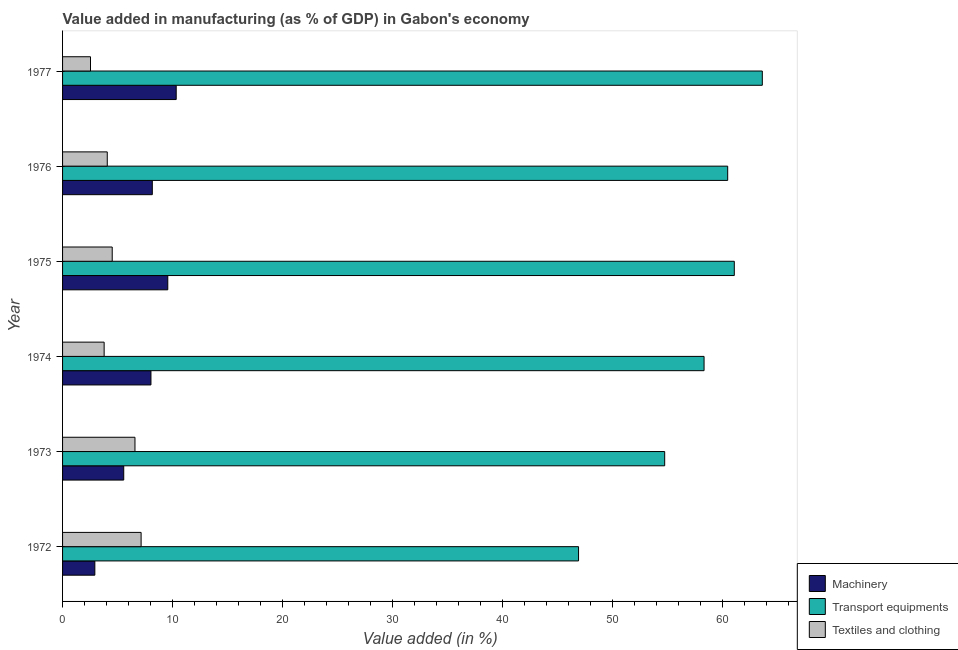How many groups of bars are there?
Give a very brief answer. 6. What is the label of the 3rd group of bars from the top?
Offer a very short reply. 1975. What is the value added in manufacturing machinery in 1977?
Keep it short and to the point. 10.33. Across all years, what is the maximum value added in manufacturing transport equipments?
Provide a short and direct response. 63.58. Across all years, what is the minimum value added in manufacturing textile and clothing?
Provide a succinct answer. 2.54. In which year was the value added in manufacturing transport equipments maximum?
Your answer should be very brief. 1977. In which year was the value added in manufacturing transport equipments minimum?
Make the answer very short. 1972. What is the total value added in manufacturing transport equipments in the graph?
Your answer should be very brief. 344.92. What is the difference between the value added in manufacturing machinery in 1974 and that in 1976?
Provide a short and direct response. -0.12. What is the difference between the value added in manufacturing machinery in 1975 and the value added in manufacturing transport equipments in 1974?
Your answer should be compact. -48.73. What is the average value added in manufacturing textile and clothing per year?
Your response must be concise. 4.77. In the year 1973, what is the difference between the value added in manufacturing transport equipments and value added in manufacturing machinery?
Your response must be concise. 49.15. What is the ratio of the value added in manufacturing textile and clothing in 1972 to that in 1975?
Your response must be concise. 1.58. Is the difference between the value added in manufacturing transport equipments in 1975 and 1977 greater than the difference between the value added in manufacturing machinery in 1975 and 1977?
Make the answer very short. No. What is the difference between the highest and the second highest value added in manufacturing machinery?
Provide a short and direct response. 0.77. Is the sum of the value added in manufacturing transport equipments in 1976 and 1977 greater than the maximum value added in manufacturing machinery across all years?
Give a very brief answer. Yes. What does the 1st bar from the top in 1976 represents?
Your answer should be compact. Textiles and clothing. What does the 1st bar from the bottom in 1976 represents?
Give a very brief answer. Machinery. Is it the case that in every year, the sum of the value added in manufacturing machinery and value added in manufacturing transport equipments is greater than the value added in manufacturing textile and clothing?
Give a very brief answer. Yes. How many bars are there?
Keep it short and to the point. 18. How many years are there in the graph?
Your answer should be very brief. 6. What is the difference between two consecutive major ticks on the X-axis?
Offer a very short reply. 10. Does the graph contain grids?
Ensure brevity in your answer.  No. Where does the legend appear in the graph?
Keep it short and to the point. Bottom right. How are the legend labels stacked?
Your answer should be compact. Vertical. What is the title of the graph?
Ensure brevity in your answer.  Value added in manufacturing (as % of GDP) in Gabon's economy. Does "Female employers" appear as one of the legend labels in the graph?
Provide a succinct answer. No. What is the label or title of the X-axis?
Give a very brief answer. Value added (in %). What is the Value added (in %) in Machinery in 1972?
Ensure brevity in your answer.  2.93. What is the Value added (in %) of Transport equipments in 1972?
Ensure brevity in your answer.  46.88. What is the Value added (in %) of Textiles and clothing in 1972?
Your answer should be compact. 7.14. What is the Value added (in %) of Machinery in 1973?
Provide a short and direct response. 5.56. What is the Value added (in %) in Transport equipments in 1973?
Your response must be concise. 54.71. What is the Value added (in %) of Textiles and clothing in 1973?
Offer a terse response. 6.58. What is the Value added (in %) in Machinery in 1974?
Your answer should be very brief. 8.03. What is the Value added (in %) of Transport equipments in 1974?
Your response must be concise. 58.29. What is the Value added (in %) in Textiles and clothing in 1974?
Offer a very short reply. 3.78. What is the Value added (in %) in Machinery in 1975?
Your response must be concise. 9.56. What is the Value added (in %) of Transport equipments in 1975?
Make the answer very short. 61.03. What is the Value added (in %) in Textiles and clothing in 1975?
Make the answer very short. 4.51. What is the Value added (in %) in Machinery in 1976?
Give a very brief answer. 8.16. What is the Value added (in %) in Transport equipments in 1976?
Offer a terse response. 60.43. What is the Value added (in %) in Textiles and clothing in 1976?
Provide a succinct answer. 4.06. What is the Value added (in %) in Machinery in 1977?
Your answer should be very brief. 10.33. What is the Value added (in %) of Transport equipments in 1977?
Provide a short and direct response. 63.58. What is the Value added (in %) of Textiles and clothing in 1977?
Provide a succinct answer. 2.54. Across all years, what is the maximum Value added (in %) in Machinery?
Offer a very short reply. 10.33. Across all years, what is the maximum Value added (in %) of Transport equipments?
Ensure brevity in your answer.  63.58. Across all years, what is the maximum Value added (in %) in Textiles and clothing?
Give a very brief answer. 7.14. Across all years, what is the minimum Value added (in %) in Machinery?
Ensure brevity in your answer.  2.93. Across all years, what is the minimum Value added (in %) in Transport equipments?
Your answer should be very brief. 46.88. Across all years, what is the minimum Value added (in %) of Textiles and clothing?
Your answer should be compact. 2.54. What is the total Value added (in %) of Machinery in the graph?
Give a very brief answer. 44.56. What is the total Value added (in %) of Transport equipments in the graph?
Make the answer very short. 344.92. What is the total Value added (in %) of Textiles and clothing in the graph?
Your answer should be very brief. 28.6. What is the difference between the Value added (in %) of Machinery in 1972 and that in 1973?
Make the answer very short. -2.62. What is the difference between the Value added (in %) in Transport equipments in 1972 and that in 1973?
Offer a very short reply. -7.83. What is the difference between the Value added (in %) in Textiles and clothing in 1972 and that in 1973?
Your answer should be compact. 0.56. What is the difference between the Value added (in %) of Machinery in 1972 and that in 1974?
Give a very brief answer. -5.1. What is the difference between the Value added (in %) of Transport equipments in 1972 and that in 1974?
Your answer should be very brief. -11.4. What is the difference between the Value added (in %) in Textiles and clothing in 1972 and that in 1974?
Offer a terse response. 3.36. What is the difference between the Value added (in %) in Machinery in 1972 and that in 1975?
Offer a very short reply. -6.63. What is the difference between the Value added (in %) in Transport equipments in 1972 and that in 1975?
Provide a succinct answer. -14.15. What is the difference between the Value added (in %) in Textiles and clothing in 1972 and that in 1975?
Your response must be concise. 2.62. What is the difference between the Value added (in %) in Machinery in 1972 and that in 1976?
Offer a very short reply. -5.22. What is the difference between the Value added (in %) in Transport equipments in 1972 and that in 1976?
Offer a terse response. -13.55. What is the difference between the Value added (in %) of Textiles and clothing in 1972 and that in 1976?
Offer a very short reply. 3.07. What is the difference between the Value added (in %) of Machinery in 1972 and that in 1977?
Provide a short and direct response. -7.39. What is the difference between the Value added (in %) in Transport equipments in 1972 and that in 1977?
Offer a terse response. -16.7. What is the difference between the Value added (in %) of Textiles and clothing in 1972 and that in 1977?
Your answer should be very brief. 4.6. What is the difference between the Value added (in %) of Machinery in 1973 and that in 1974?
Provide a short and direct response. -2.47. What is the difference between the Value added (in %) of Transport equipments in 1973 and that in 1974?
Provide a short and direct response. -3.58. What is the difference between the Value added (in %) in Textiles and clothing in 1973 and that in 1974?
Offer a terse response. 2.8. What is the difference between the Value added (in %) in Machinery in 1973 and that in 1975?
Your answer should be very brief. -4. What is the difference between the Value added (in %) in Transport equipments in 1973 and that in 1975?
Make the answer very short. -6.32. What is the difference between the Value added (in %) in Textiles and clothing in 1973 and that in 1975?
Offer a very short reply. 2.07. What is the difference between the Value added (in %) of Machinery in 1973 and that in 1976?
Offer a terse response. -2.6. What is the difference between the Value added (in %) in Transport equipments in 1973 and that in 1976?
Provide a short and direct response. -5.72. What is the difference between the Value added (in %) of Textiles and clothing in 1973 and that in 1976?
Your response must be concise. 2.52. What is the difference between the Value added (in %) in Machinery in 1973 and that in 1977?
Ensure brevity in your answer.  -4.77. What is the difference between the Value added (in %) of Transport equipments in 1973 and that in 1977?
Offer a terse response. -8.87. What is the difference between the Value added (in %) in Textiles and clothing in 1973 and that in 1977?
Offer a very short reply. 4.04. What is the difference between the Value added (in %) of Machinery in 1974 and that in 1975?
Make the answer very short. -1.53. What is the difference between the Value added (in %) in Transport equipments in 1974 and that in 1975?
Provide a succinct answer. -2.75. What is the difference between the Value added (in %) of Textiles and clothing in 1974 and that in 1975?
Your answer should be compact. -0.73. What is the difference between the Value added (in %) in Machinery in 1974 and that in 1976?
Make the answer very short. -0.12. What is the difference between the Value added (in %) in Transport equipments in 1974 and that in 1976?
Make the answer very short. -2.15. What is the difference between the Value added (in %) of Textiles and clothing in 1974 and that in 1976?
Offer a terse response. -0.28. What is the difference between the Value added (in %) in Machinery in 1974 and that in 1977?
Ensure brevity in your answer.  -2.29. What is the difference between the Value added (in %) in Transport equipments in 1974 and that in 1977?
Give a very brief answer. -5.29. What is the difference between the Value added (in %) in Textiles and clothing in 1974 and that in 1977?
Your answer should be very brief. 1.24. What is the difference between the Value added (in %) in Machinery in 1975 and that in 1976?
Your response must be concise. 1.41. What is the difference between the Value added (in %) in Transport equipments in 1975 and that in 1976?
Ensure brevity in your answer.  0.6. What is the difference between the Value added (in %) of Textiles and clothing in 1975 and that in 1976?
Make the answer very short. 0.45. What is the difference between the Value added (in %) in Machinery in 1975 and that in 1977?
Offer a terse response. -0.77. What is the difference between the Value added (in %) in Transport equipments in 1975 and that in 1977?
Keep it short and to the point. -2.55. What is the difference between the Value added (in %) in Textiles and clothing in 1975 and that in 1977?
Make the answer very short. 1.97. What is the difference between the Value added (in %) in Machinery in 1976 and that in 1977?
Provide a short and direct response. -2.17. What is the difference between the Value added (in %) of Transport equipments in 1976 and that in 1977?
Give a very brief answer. -3.15. What is the difference between the Value added (in %) of Textiles and clothing in 1976 and that in 1977?
Your answer should be compact. 1.52. What is the difference between the Value added (in %) in Machinery in 1972 and the Value added (in %) in Transport equipments in 1973?
Your answer should be very brief. -51.78. What is the difference between the Value added (in %) in Machinery in 1972 and the Value added (in %) in Textiles and clothing in 1973?
Make the answer very short. -3.65. What is the difference between the Value added (in %) of Transport equipments in 1972 and the Value added (in %) of Textiles and clothing in 1973?
Your response must be concise. 40.3. What is the difference between the Value added (in %) of Machinery in 1972 and the Value added (in %) of Transport equipments in 1974?
Ensure brevity in your answer.  -55.35. What is the difference between the Value added (in %) in Machinery in 1972 and the Value added (in %) in Textiles and clothing in 1974?
Ensure brevity in your answer.  -0.85. What is the difference between the Value added (in %) in Transport equipments in 1972 and the Value added (in %) in Textiles and clothing in 1974?
Your answer should be very brief. 43.1. What is the difference between the Value added (in %) in Machinery in 1972 and the Value added (in %) in Transport equipments in 1975?
Your answer should be very brief. -58.1. What is the difference between the Value added (in %) of Machinery in 1972 and the Value added (in %) of Textiles and clothing in 1975?
Keep it short and to the point. -1.58. What is the difference between the Value added (in %) of Transport equipments in 1972 and the Value added (in %) of Textiles and clothing in 1975?
Make the answer very short. 42.37. What is the difference between the Value added (in %) in Machinery in 1972 and the Value added (in %) in Transport equipments in 1976?
Keep it short and to the point. -57.5. What is the difference between the Value added (in %) in Machinery in 1972 and the Value added (in %) in Textiles and clothing in 1976?
Ensure brevity in your answer.  -1.13. What is the difference between the Value added (in %) in Transport equipments in 1972 and the Value added (in %) in Textiles and clothing in 1976?
Give a very brief answer. 42.82. What is the difference between the Value added (in %) of Machinery in 1972 and the Value added (in %) of Transport equipments in 1977?
Offer a terse response. -60.65. What is the difference between the Value added (in %) in Machinery in 1972 and the Value added (in %) in Textiles and clothing in 1977?
Give a very brief answer. 0.4. What is the difference between the Value added (in %) in Transport equipments in 1972 and the Value added (in %) in Textiles and clothing in 1977?
Offer a terse response. 44.34. What is the difference between the Value added (in %) of Machinery in 1973 and the Value added (in %) of Transport equipments in 1974?
Your answer should be very brief. -52.73. What is the difference between the Value added (in %) of Machinery in 1973 and the Value added (in %) of Textiles and clothing in 1974?
Provide a short and direct response. 1.78. What is the difference between the Value added (in %) in Transport equipments in 1973 and the Value added (in %) in Textiles and clothing in 1974?
Provide a short and direct response. 50.93. What is the difference between the Value added (in %) of Machinery in 1973 and the Value added (in %) of Transport equipments in 1975?
Keep it short and to the point. -55.48. What is the difference between the Value added (in %) in Machinery in 1973 and the Value added (in %) in Textiles and clothing in 1975?
Ensure brevity in your answer.  1.05. What is the difference between the Value added (in %) in Transport equipments in 1973 and the Value added (in %) in Textiles and clothing in 1975?
Ensure brevity in your answer.  50.2. What is the difference between the Value added (in %) in Machinery in 1973 and the Value added (in %) in Transport equipments in 1976?
Ensure brevity in your answer.  -54.88. What is the difference between the Value added (in %) in Machinery in 1973 and the Value added (in %) in Textiles and clothing in 1976?
Make the answer very short. 1.5. What is the difference between the Value added (in %) of Transport equipments in 1973 and the Value added (in %) of Textiles and clothing in 1976?
Your response must be concise. 50.65. What is the difference between the Value added (in %) of Machinery in 1973 and the Value added (in %) of Transport equipments in 1977?
Make the answer very short. -58.02. What is the difference between the Value added (in %) in Machinery in 1973 and the Value added (in %) in Textiles and clothing in 1977?
Your answer should be compact. 3.02. What is the difference between the Value added (in %) in Transport equipments in 1973 and the Value added (in %) in Textiles and clothing in 1977?
Offer a very short reply. 52.17. What is the difference between the Value added (in %) of Machinery in 1974 and the Value added (in %) of Transport equipments in 1975?
Provide a short and direct response. -53. What is the difference between the Value added (in %) of Machinery in 1974 and the Value added (in %) of Textiles and clothing in 1975?
Give a very brief answer. 3.52. What is the difference between the Value added (in %) in Transport equipments in 1974 and the Value added (in %) in Textiles and clothing in 1975?
Your answer should be compact. 53.78. What is the difference between the Value added (in %) in Machinery in 1974 and the Value added (in %) in Transport equipments in 1976?
Your answer should be very brief. -52.4. What is the difference between the Value added (in %) of Machinery in 1974 and the Value added (in %) of Textiles and clothing in 1976?
Offer a terse response. 3.97. What is the difference between the Value added (in %) in Transport equipments in 1974 and the Value added (in %) in Textiles and clothing in 1976?
Keep it short and to the point. 54.22. What is the difference between the Value added (in %) in Machinery in 1974 and the Value added (in %) in Transport equipments in 1977?
Provide a succinct answer. -55.55. What is the difference between the Value added (in %) of Machinery in 1974 and the Value added (in %) of Textiles and clothing in 1977?
Your answer should be very brief. 5.49. What is the difference between the Value added (in %) of Transport equipments in 1974 and the Value added (in %) of Textiles and clothing in 1977?
Your answer should be very brief. 55.75. What is the difference between the Value added (in %) in Machinery in 1975 and the Value added (in %) in Transport equipments in 1976?
Your answer should be compact. -50.87. What is the difference between the Value added (in %) of Machinery in 1975 and the Value added (in %) of Textiles and clothing in 1976?
Your answer should be very brief. 5.5. What is the difference between the Value added (in %) in Transport equipments in 1975 and the Value added (in %) in Textiles and clothing in 1976?
Give a very brief answer. 56.97. What is the difference between the Value added (in %) in Machinery in 1975 and the Value added (in %) in Transport equipments in 1977?
Provide a short and direct response. -54.02. What is the difference between the Value added (in %) in Machinery in 1975 and the Value added (in %) in Textiles and clothing in 1977?
Provide a succinct answer. 7.02. What is the difference between the Value added (in %) in Transport equipments in 1975 and the Value added (in %) in Textiles and clothing in 1977?
Give a very brief answer. 58.5. What is the difference between the Value added (in %) of Machinery in 1976 and the Value added (in %) of Transport equipments in 1977?
Keep it short and to the point. -55.42. What is the difference between the Value added (in %) in Machinery in 1976 and the Value added (in %) in Textiles and clothing in 1977?
Make the answer very short. 5.62. What is the difference between the Value added (in %) in Transport equipments in 1976 and the Value added (in %) in Textiles and clothing in 1977?
Give a very brief answer. 57.9. What is the average Value added (in %) in Machinery per year?
Provide a short and direct response. 7.43. What is the average Value added (in %) in Transport equipments per year?
Offer a very short reply. 57.49. What is the average Value added (in %) in Textiles and clothing per year?
Make the answer very short. 4.77. In the year 1972, what is the difference between the Value added (in %) in Machinery and Value added (in %) in Transport equipments?
Your response must be concise. -43.95. In the year 1972, what is the difference between the Value added (in %) in Machinery and Value added (in %) in Textiles and clothing?
Make the answer very short. -4.2. In the year 1972, what is the difference between the Value added (in %) of Transport equipments and Value added (in %) of Textiles and clothing?
Ensure brevity in your answer.  39.75. In the year 1973, what is the difference between the Value added (in %) in Machinery and Value added (in %) in Transport equipments?
Make the answer very short. -49.15. In the year 1973, what is the difference between the Value added (in %) of Machinery and Value added (in %) of Textiles and clothing?
Make the answer very short. -1.02. In the year 1973, what is the difference between the Value added (in %) in Transport equipments and Value added (in %) in Textiles and clothing?
Keep it short and to the point. 48.13. In the year 1974, what is the difference between the Value added (in %) of Machinery and Value added (in %) of Transport equipments?
Make the answer very short. -50.26. In the year 1974, what is the difference between the Value added (in %) of Machinery and Value added (in %) of Textiles and clothing?
Ensure brevity in your answer.  4.25. In the year 1974, what is the difference between the Value added (in %) in Transport equipments and Value added (in %) in Textiles and clothing?
Provide a short and direct response. 54.51. In the year 1975, what is the difference between the Value added (in %) in Machinery and Value added (in %) in Transport equipments?
Make the answer very short. -51.47. In the year 1975, what is the difference between the Value added (in %) in Machinery and Value added (in %) in Textiles and clothing?
Make the answer very short. 5.05. In the year 1975, what is the difference between the Value added (in %) in Transport equipments and Value added (in %) in Textiles and clothing?
Your answer should be compact. 56.52. In the year 1976, what is the difference between the Value added (in %) of Machinery and Value added (in %) of Transport equipments?
Provide a succinct answer. -52.28. In the year 1976, what is the difference between the Value added (in %) in Machinery and Value added (in %) in Textiles and clothing?
Provide a short and direct response. 4.09. In the year 1976, what is the difference between the Value added (in %) of Transport equipments and Value added (in %) of Textiles and clothing?
Provide a short and direct response. 56.37. In the year 1977, what is the difference between the Value added (in %) of Machinery and Value added (in %) of Transport equipments?
Provide a succinct answer. -53.25. In the year 1977, what is the difference between the Value added (in %) in Machinery and Value added (in %) in Textiles and clothing?
Ensure brevity in your answer.  7.79. In the year 1977, what is the difference between the Value added (in %) in Transport equipments and Value added (in %) in Textiles and clothing?
Your answer should be compact. 61.04. What is the ratio of the Value added (in %) in Machinery in 1972 to that in 1973?
Ensure brevity in your answer.  0.53. What is the ratio of the Value added (in %) in Transport equipments in 1972 to that in 1973?
Your answer should be very brief. 0.86. What is the ratio of the Value added (in %) of Textiles and clothing in 1972 to that in 1973?
Your response must be concise. 1.08. What is the ratio of the Value added (in %) in Machinery in 1972 to that in 1974?
Provide a succinct answer. 0.37. What is the ratio of the Value added (in %) in Transport equipments in 1972 to that in 1974?
Provide a short and direct response. 0.8. What is the ratio of the Value added (in %) of Textiles and clothing in 1972 to that in 1974?
Provide a succinct answer. 1.89. What is the ratio of the Value added (in %) in Machinery in 1972 to that in 1975?
Your answer should be compact. 0.31. What is the ratio of the Value added (in %) in Transport equipments in 1972 to that in 1975?
Ensure brevity in your answer.  0.77. What is the ratio of the Value added (in %) of Textiles and clothing in 1972 to that in 1975?
Give a very brief answer. 1.58. What is the ratio of the Value added (in %) of Machinery in 1972 to that in 1976?
Your response must be concise. 0.36. What is the ratio of the Value added (in %) of Transport equipments in 1972 to that in 1976?
Provide a short and direct response. 0.78. What is the ratio of the Value added (in %) of Textiles and clothing in 1972 to that in 1976?
Offer a very short reply. 1.76. What is the ratio of the Value added (in %) of Machinery in 1972 to that in 1977?
Offer a terse response. 0.28. What is the ratio of the Value added (in %) in Transport equipments in 1972 to that in 1977?
Your answer should be very brief. 0.74. What is the ratio of the Value added (in %) in Textiles and clothing in 1972 to that in 1977?
Offer a terse response. 2.81. What is the ratio of the Value added (in %) of Machinery in 1973 to that in 1974?
Offer a terse response. 0.69. What is the ratio of the Value added (in %) in Transport equipments in 1973 to that in 1974?
Offer a very short reply. 0.94. What is the ratio of the Value added (in %) of Textiles and clothing in 1973 to that in 1974?
Provide a succinct answer. 1.74. What is the ratio of the Value added (in %) of Machinery in 1973 to that in 1975?
Make the answer very short. 0.58. What is the ratio of the Value added (in %) of Transport equipments in 1973 to that in 1975?
Make the answer very short. 0.9. What is the ratio of the Value added (in %) in Textiles and clothing in 1973 to that in 1975?
Provide a short and direct response. 1.46. What is the ratio of the Value added (in %) of Machinery in 1973 to that in 1976?
Keep it short and to the point. 0.68. What is the ratio of the Value added (in %) in Transport equipments in 1973 to that in 1976?
Provide a short and direct response. 0.91. What is the ratio of the Value added (in %) of Textiles and clothing in 1973 to that in 1976?
Offer a terse response. 1.62. What is the ratio of the Value added (in %) of Machinery in 1973 to that in 1977?
Your response must be concise. 0.54. What is the ratio of the Value added (in %) in Transport equipments in 1973 to that in 1977?
Make the answer very short. 0.86. What is the ratio of the Value added (in %) of Textiles and clothing in 1973 to that in 1977?
Keep it short and to the point. 2.59. What is the ratio of the Value added (in %) of Machinery in 1974 to that in 1975?
Give a very brief answer. 0.84. What is the ratio of the Value added (in %) in Transport equipments in 1974 to that in 1975?
Your answer should be very brief. 0.95. What is the ratio of the Value added (in %) of Textiles and clothing in 1974 to that in 1975?
Ensure brevity in your answer.  0.84. What is the ratio of the Value added (in %) of Machinery in 1974 to that in 1976?
Provide a succinct answer. 0.98. What is the ratio of the Value added (in %) in Transport equipments in 1974 to that in 1976?
Make the answer very short. 0.96. What is the ratio of the Value added (in %) of Textiles and clothing in 1974 to that in 1976?
Give a very brief answer. 0.93. What is the ratio of the Value added (in %) of Machinery in 1974 to that in 1977?
Keep it short and to the point. 0.78. What is the ratio of the Value added (in %) of Transport equipments in 1974 to that in 1977?
Your answer should be compact. 0.92. What is the ratio of the Value added (in %) in Textiles and clothing in 1974 to that in 1977?
Provide a succinct answer. 1.49. What is the ratio of the Value added (in %) of Machinery in 1975 to that in 1976?
Ensure brevity in your answer.  1.17. What is the ratio of the Value added (in %) of Transport equipments in 1975 to that in 1976?
Provide a short and direct response. 1.01. What is the ratio of the Value added (in %) in Textiles and clothing in 1975 to that in 1976?
Your answer should be compact. 1.11. What is the ratio of the Value added (in %) in Machinery in 1975 to that in 1977?
Ensure brevity in your answer.  0.93. What is the ratio of the Value added (in %) of Transport equipments in 1975 to that in 1977?
Provide a short and direct response. 0.96. What is the ratio of the Value added (in %) of Textiles and clothing in 1975 to that in 1977?
Your response must be concise. 1.78. What is the ratio of the Value added (in %) of Machinery in 1976 to that in 1977?
Make the answer very short. 0.79. What is the ratio of the Value added (in %) of Transport equipments in 1976 to that in 1977?
Your response must be concise. 0.95. What is the ratio of the Value added (in %) of Textiles and clothing in 1976 to that in 1977?
Your answer should be very brief. 1.6. What is the difference between the highest and the second highest Value added (in %) in Machinery?
Make the answer very short. 0.77. What is the difference between the highest and the second highest Value added (in %) of Transport equipments?
Make the answer very short. 2.55. What is the difference between the highest and the second highest Value added (in %) in Textiles and clothing?
Your answer should be very brief. 0.56. What is the difference between the highest and the lowest Value added (in %) in Machinery?
Ensure brevity in your answer.  7.39. What is the difference between the highest and the lowest Value added (in %) of Transport equipments?
Your answer should be very brief. 16.7. What is the difference between the highest and the lowest Value added (in %) in Textiles and clothing?
Keep it short and to the point. 4.6. 